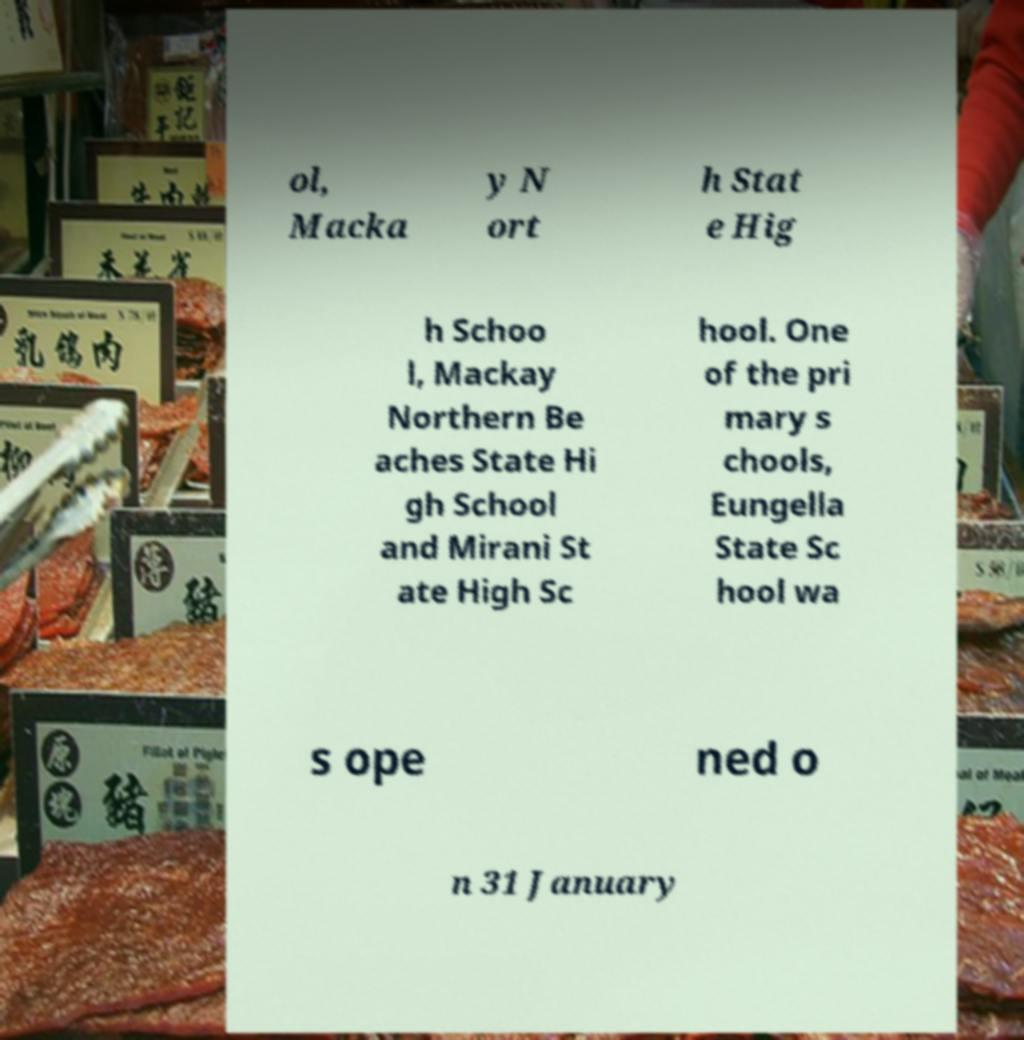There's text embedded in this image that I need extracted. Can you transcribe it verbatim? ol, Macka y N ort h Stat e Hig h Schoo l, Mackay Northern Be aches State Hi gh School and Mirani St ate High Sc hool. One of the pri mary s chools, Eungella State Sc hool wa s ope ned o n 31 January 